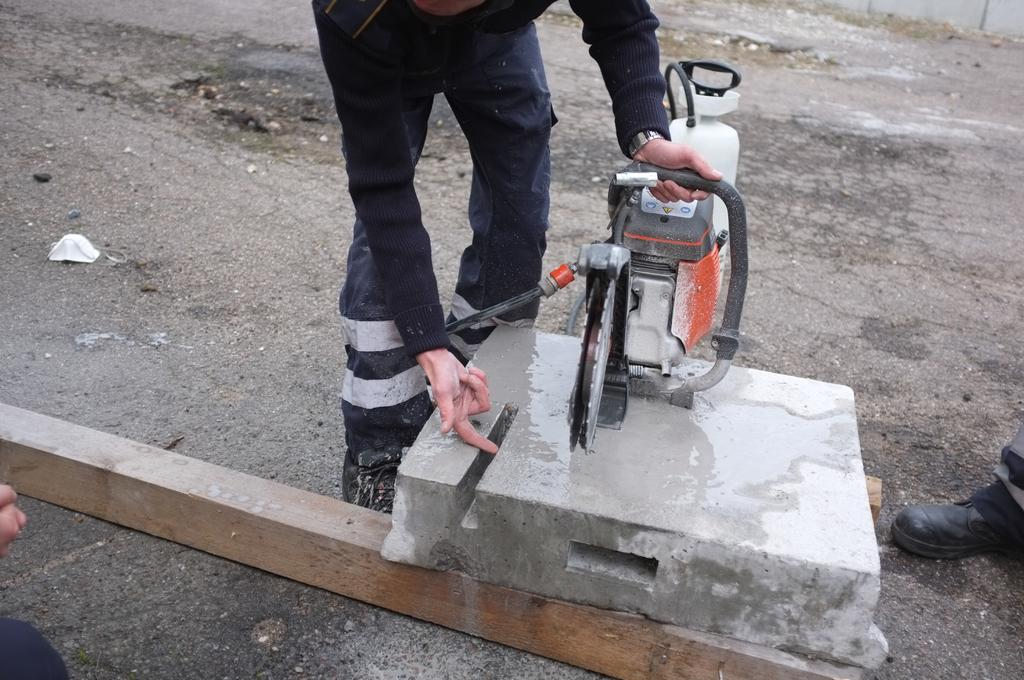Who or what is present in the image? There are people in the image. What are the people wearing? The people are wearing clothes and shoes. What objects can be seen in the image besides the people? There is an electronic device, a wooden log, and a road in the image. How many bears can be seen interacting with the wooden log in the image? There are no bears present in the image; it features people, an electronic device, a wooden log, and a road. What type of snake is slithering across the road in the image? There is no snake present in the image; it features people, an electronic device, a wooden log, and a road. 